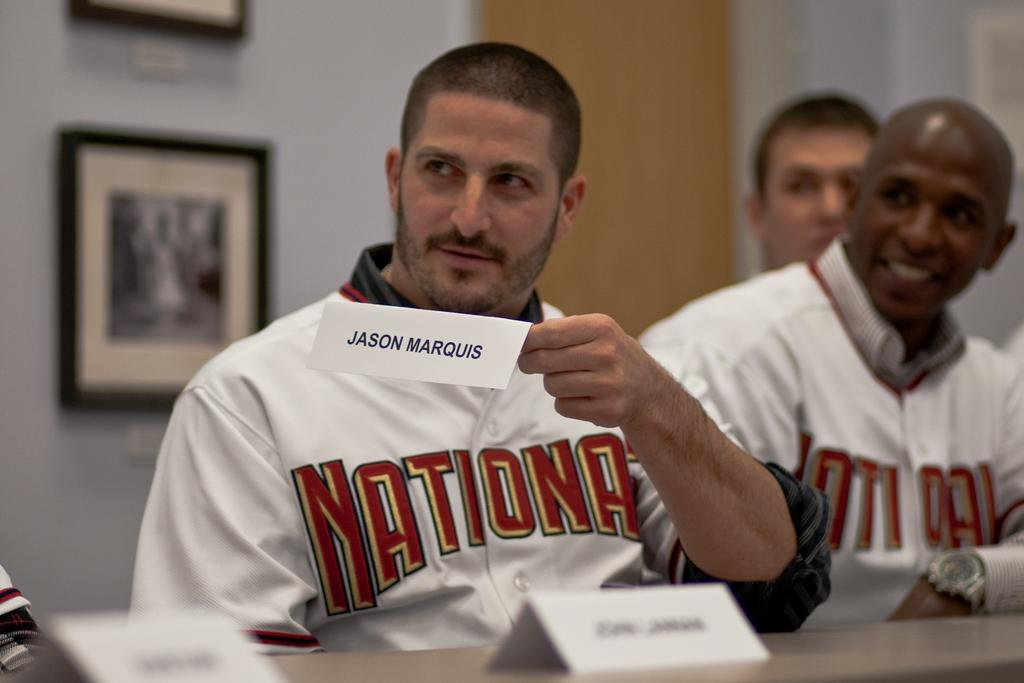Provide a one-sentence caption for the provided image. Man holding a rectangular white card with Jason Marquis in black lettering. 